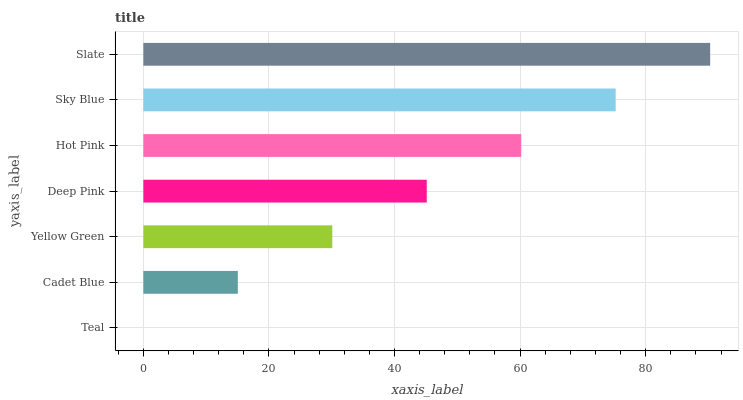Is Teal the minimum?
Answer yes or no. Yes. Is Slate the maximum?
Answer yes or no. Yes. Is Cadet Blue the minimum?
Answer yes or no. No. Is Cadet Blue the maximum?
Answer yes or no. No. Is Cadet Blue greater than Teal?
Answer yes or no. Yes. Is Teal less than Cadet Blue?
Answer yes or no. Yes. Is Teal greater than Cadet Blue?
Answer yes or no. No. Is Cadet Blue less than Teal?
Answer yes or no. No. Is Deep Pink the high median?
Answer yes or no. Yes. Is Deep Pink the low median?
Answer yes or no. Yes. Is Sky Blue the high median?
Answer yes or no. No. Is Cadet Blue the low median?
Answer yes or no. No. 